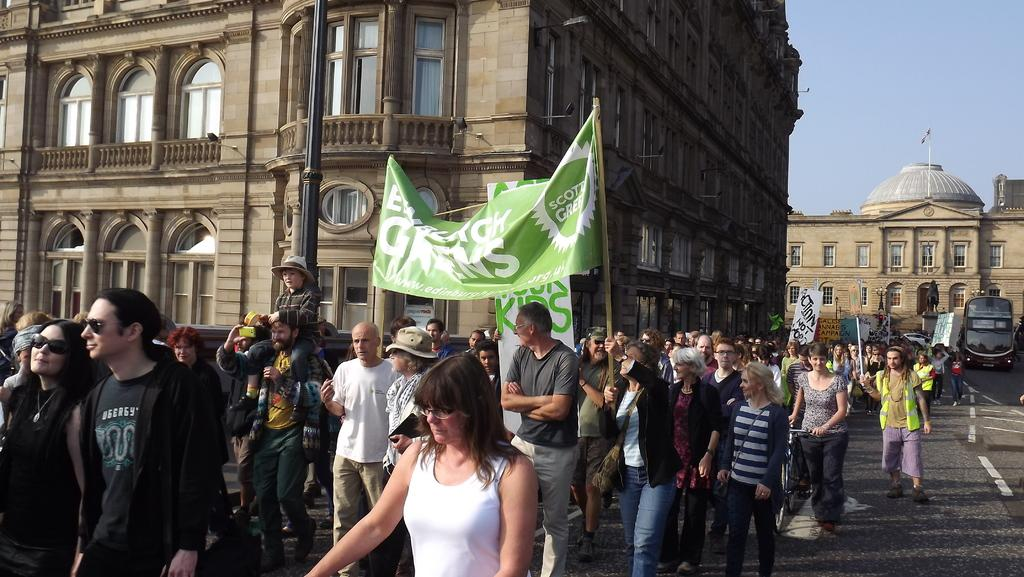What is the main subject in the center of the image? There are buildings in the center of the image. What are the people at the bottom of the image doing? The people are walking at the bottom of the image, and they are holding boards and banners. What can be seen in the background of the image? There is a car visible in the background of the image, and the sky is also visible. What is the price of the bed in the image? There is no bed present in the image, so it is not possible to determine the price. 